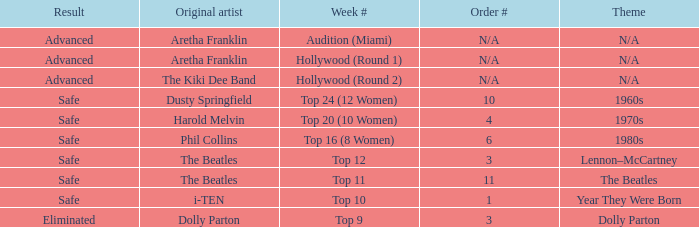What is the week number that has Dolly Parton as the theme? Top 9. 